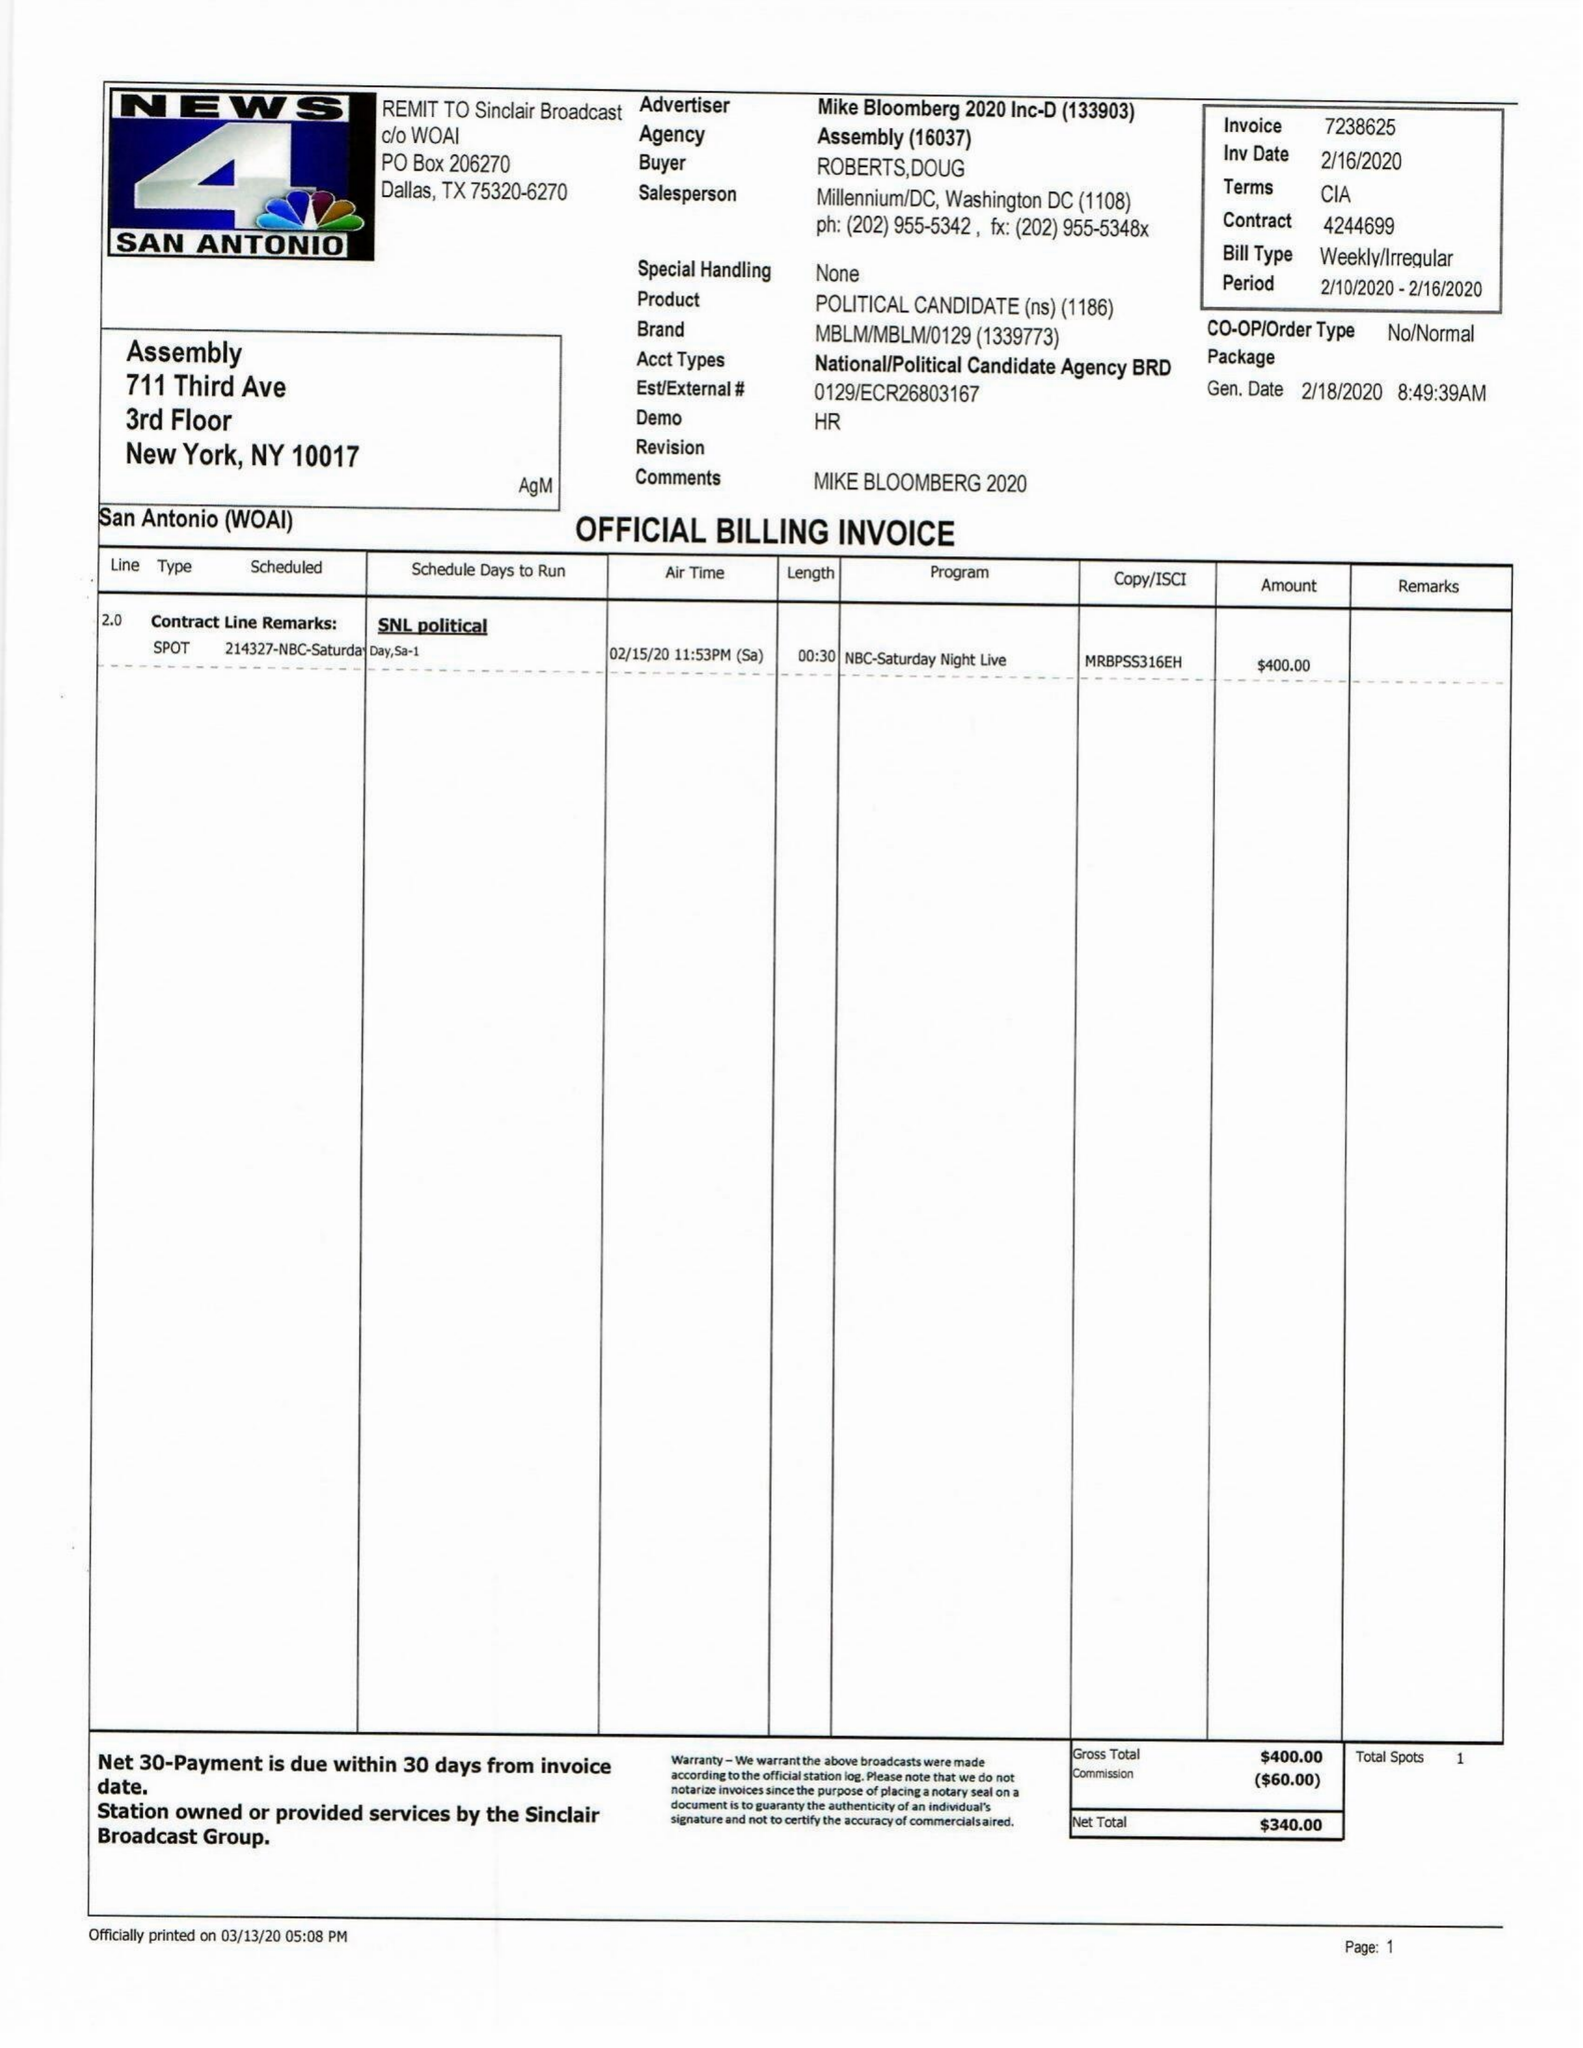What is the value for the gross_amount?
Answer the question using a single word or phrase. 2500.00 